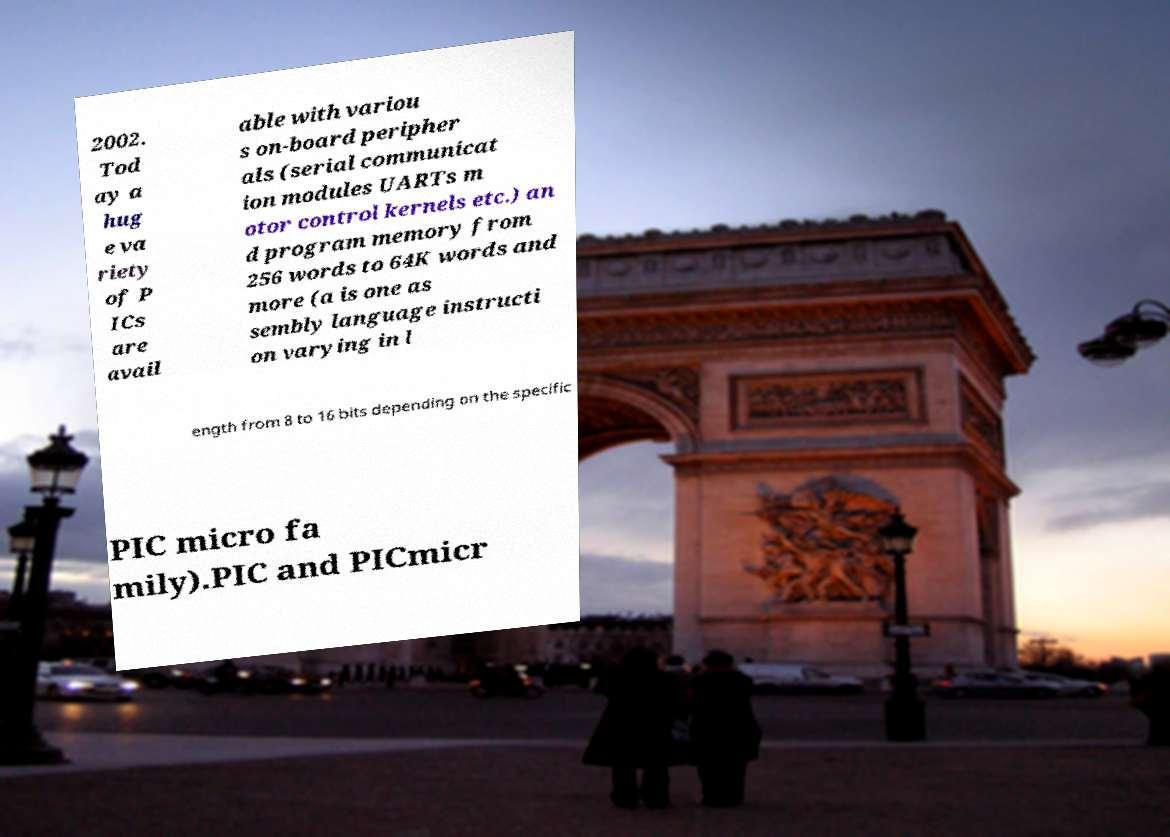For documentation purposes, I need the text within this image transcribed. Could you provide that? 2002. Tod ay a hug e va riety of P ICs are avail able with variou s on-board peripher als (serial communicat ion modules UARTs m otor control kernels etc.) an d program memory from 256 words to 64K words and more (a is one as sembly language instructi on varying in l ength from 8 to 16 bits depending on the specific PIC micro fa mily).PIC and PICmicr 